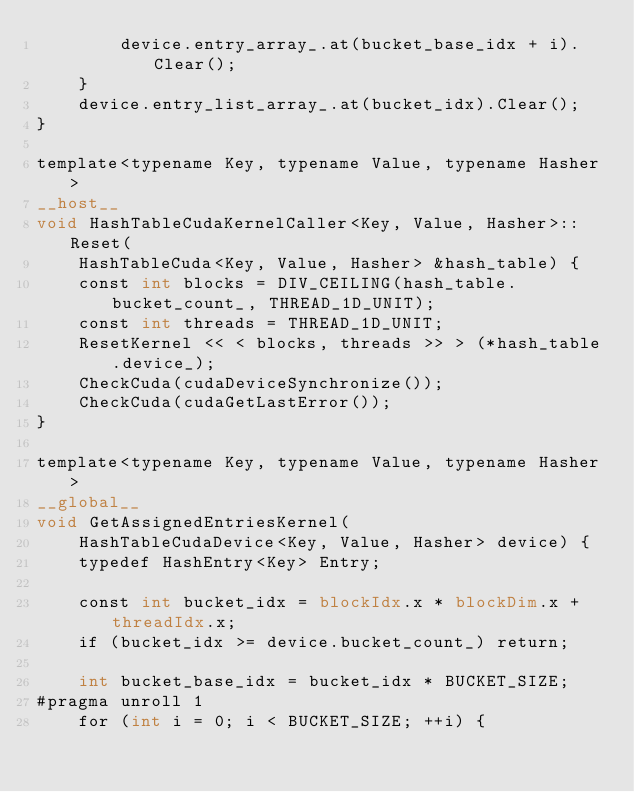Convert code to text. <code><loc_0><loc_0><loc_500><loc_500><_Cuda_>        device.entry_array_.at(bucket_base_idx + i).Clear();
    }
    device.entry_list_array_.at(bucket_idx).Clear();
}

template<typename Key, typename Value, typename Hasher>
__host__
void HashTableCudaKernelCaller<Key, Value, Hasher>::Reset(
    HashTableCuda<Key, Value, Hasher> &hash_table) {
    const int blocks = DIV_CEILING(hash_table.bucket_count_, THREAD_1D_UNIT);
    const int threads = THREAD_1D_UNIT;
    ResetKernel << < blocks, threads >> > (*hash_table.device_);
    CheckCuda(cudaDeviceSynchronize());
    CheckCuda(cudaGetLastError());
}

template<typename Key, typename Value, typename Hasher>
__global__
void GetAssignedEntriesKernel(
    HashTableCudaDevice<Key, Value, Hasher> device) {
    typedef HashEntry<Key> Entry;

    const int bucket_idx = blockIdx.x * blockDim.x + threadIdx.x;
    if (bucket_idx >= device.bucket_count_) return;

    int bucket_base_idx = bucket_idx * BUCKET_SIZE;
#pragma unroll 1
    for (int i = 0; i < BUCKET_SIZE; ++i) {</code> 